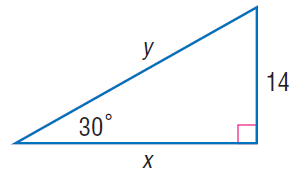Question: Find y.
Choices:
A. 12
B. 23
C. 28
D. 43
Answer with the letter. Answer: C Question: Find x.
Choices:
A. 8 \sqrt { 3 }
B. 10 \sqrt { 3 }
C. 12 \sqrt { 3 }
D. 14 \sqrt { 3 }
Answer with the letter. Answer: D 